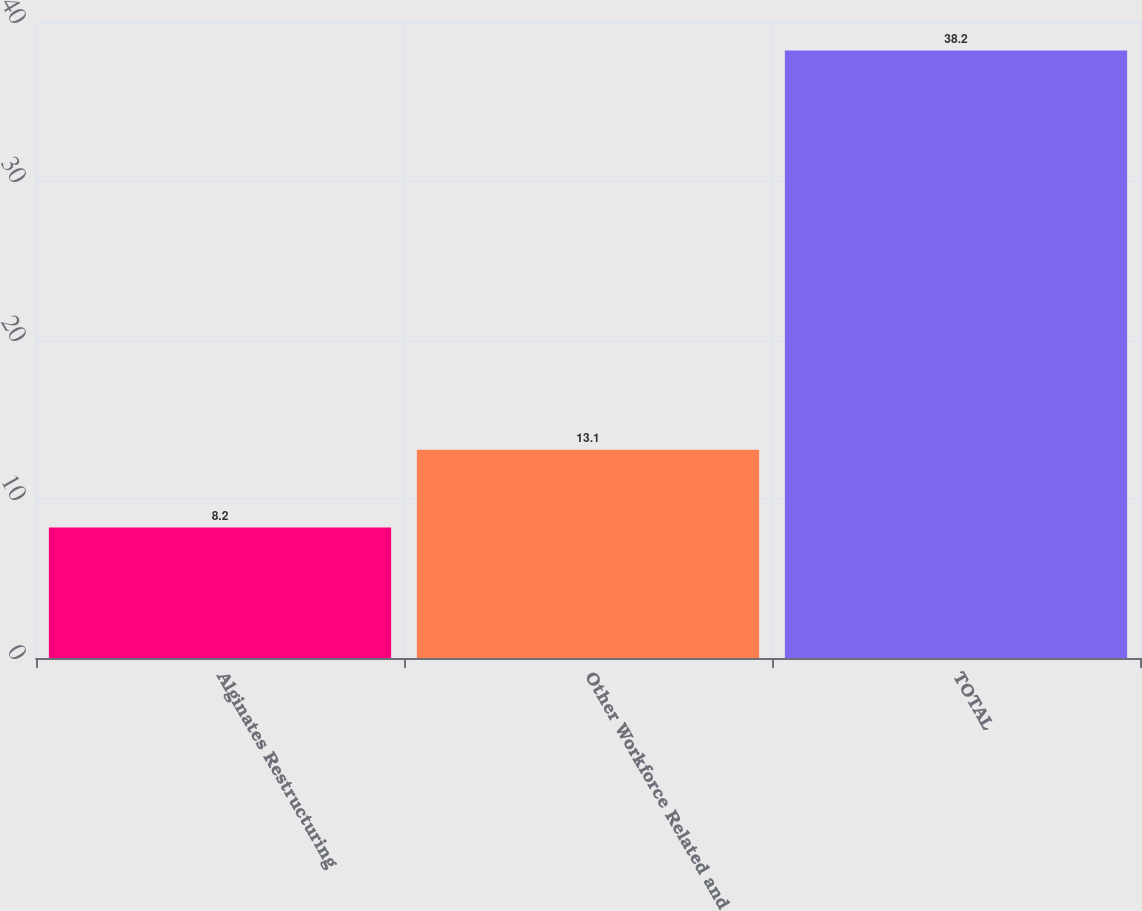<chart> <loc_0><loc_0><loc_500><loc_500><bar_chart><fcel>Alginates Restructuring<fcel>Other Workforce Related and<fcel>TOTAL<nl><fcel>8.2<fcel>13.1<fcel>38.2<nl></chart> 